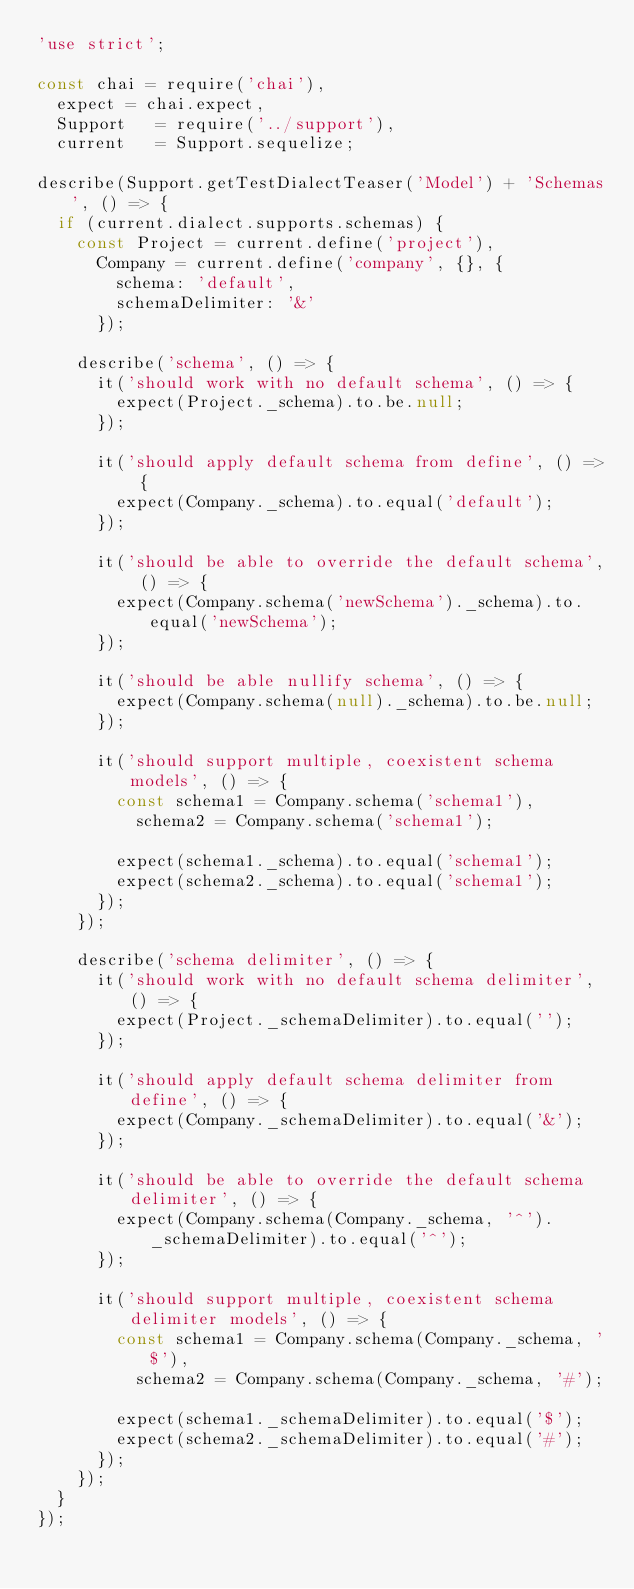Convert code to text. <code><loc_0><loc_0><loc_500><loc_500><_JavaScript_>'use strict';

const chai = require('chai'),
  expect = chai.expect,
  Support   = require('../support'),
  current   = Support.sequelize;

describe(Support.getTestDialectTeaser('Model') + 'Schemas', () => {
  if (current.dialect.supports.schemas) {
    const Project = current.define('project'),
      Company = current.define('company', {}, {
        schema: 'default',
        schemaDelimiter: '&'
      });

    describe('schema', () => {
      it('should work with no default schema', () => {
        expect(Project._schema).to.be.null;
      });

      it('should apply default schema from define', () => {
        expect(Company._schema).to.equal('default');
      });

      it('should be able to override the default schema', () => {
        expect(Company.schema('newSchema')._schema).to.equal('newSchema');
      });

      it('should be able nullify schema', () => {
        expect(Company.schema(null)._schema).to.be.null;
      });

      it('should support multiple, coexistent schema models', () => {
        const schema1 = Company.schema('schema1'),
          schema2 = Company.schema('schema1');

        expect(schema1._schema).to.equal('schema1');
        expect(schema2._schema).to.equal('schema1');
      });
    });

    describe('schema delimiter', () => {
      it('should work with no default schema delimiter', () => {
        expect(Project._schemaDelimiter).to.equal('');
      });

      it('should apply default schema delimiter from define', () => {
        expect(Company._schemaDelimiter).to.equal('&');
      });

      it('should be able to override the default schema delimiter', () => {
        expect(Company.schema(Company._schema, '^')._schemaDelimiter).to.equal('^');
      });

      it('should support multiple, coexistent schema delimiter models', () => {
        const schema1 = Company.schema(Company._schema, '$'),
          schema2 = Company.schema(Company._schema, '#');

        expect(schema1._schemaDelimiter).to.equal('$');
        expect(schema2._schemaDelimiter).to.equal('#');
      });
    });
  }
});
</code> 